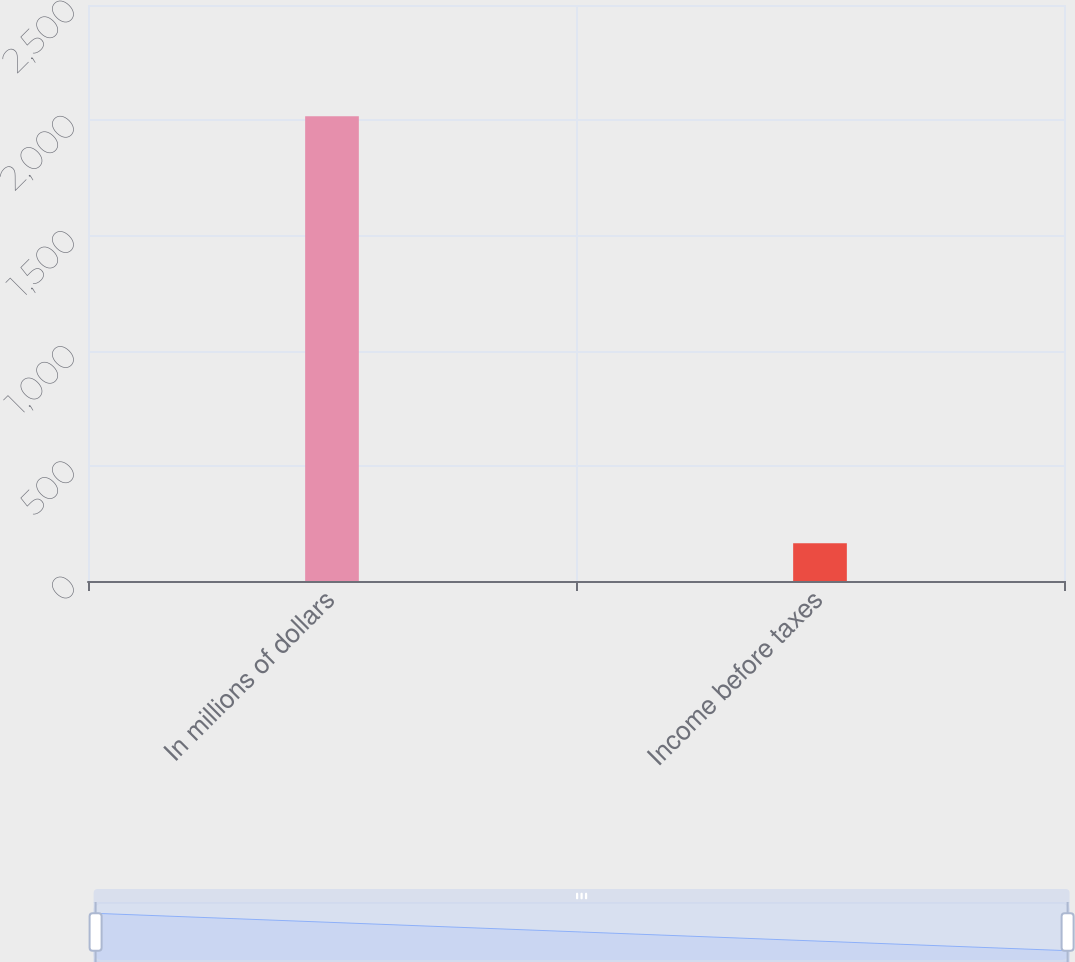<chart> <loc_0><loc_0><loc_500><loc_500><bar_chart><fcel>In millions of dollars<fcel>Income before taxes<nl><fcel>2017<fcel>164<nl></chart> 